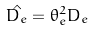Convert formula to latex. <formula><loc_0><loc_0><loc_500><loc_500>\hat { D _ { e } } = \theta _ { e } ^ { 2 } D _ { e }</formula> 